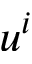Convert formula to latex. <formula><loc_0><loc_0><loc_500><loc_500>u ^ { i }</formula> 